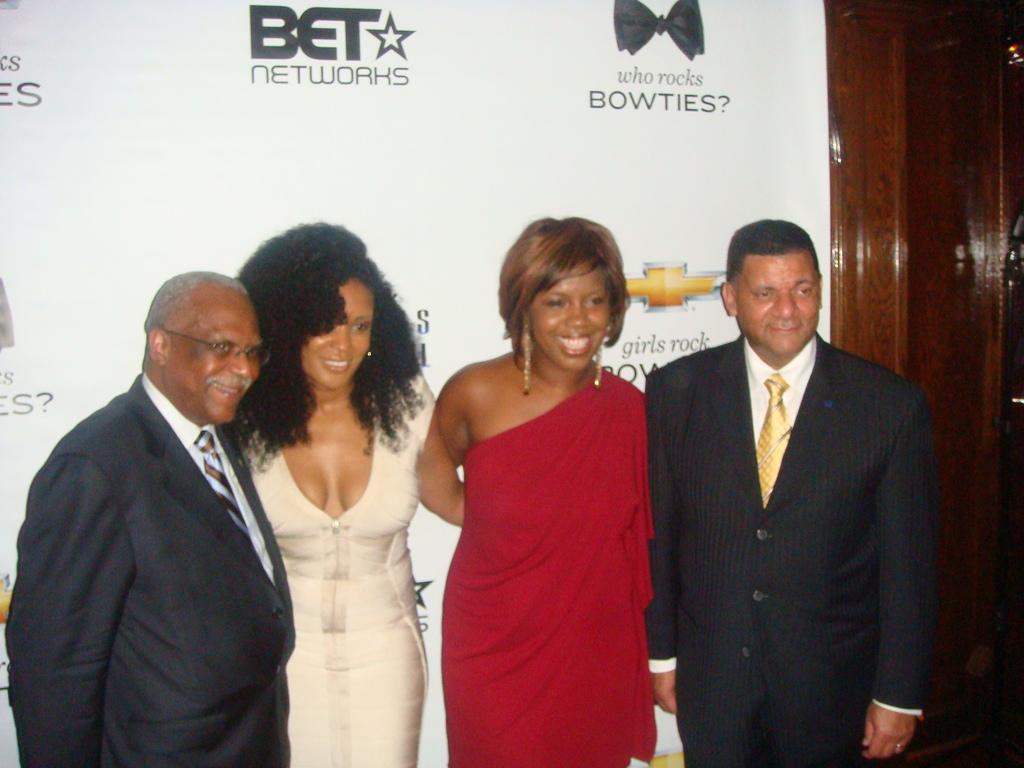Could you give a brief overview of what you see in this image? In this image I can see 4 people standing and smiling. 2 people standing on the corners are wearing suit. There is a banner at the back. 